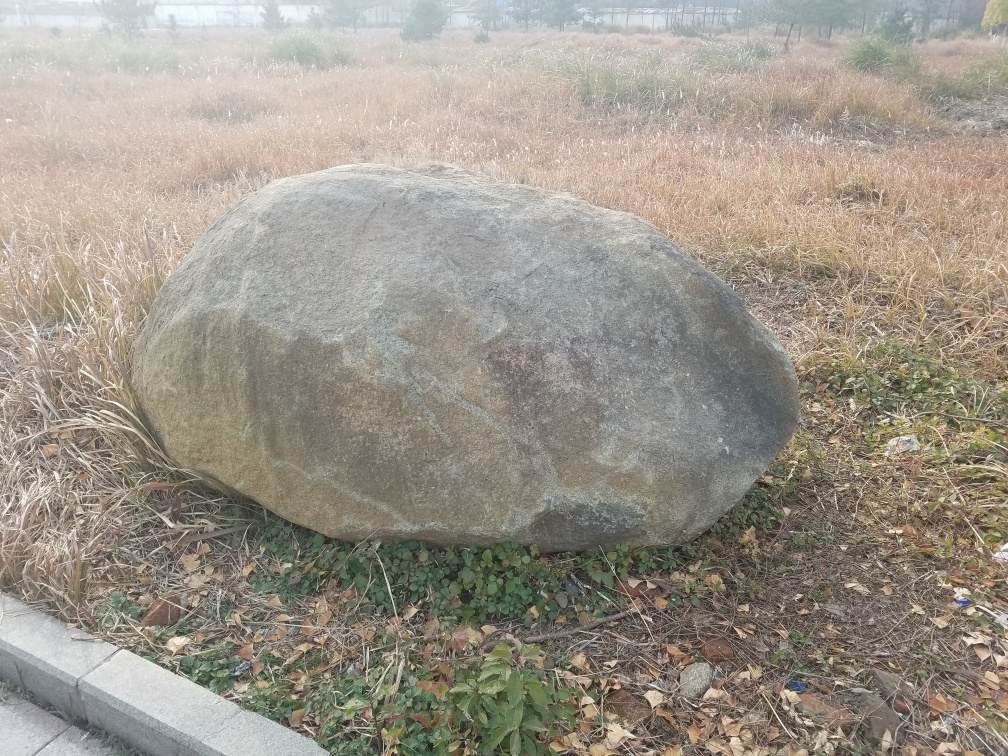What could be the geological significance of this boulder? Boulders like this one can be quite significant in geological terms. They are often transported by glacial ice or water flows from their original location, a process known as glacial erratic. Their composition, size, and location can give clues about past natural events, such as ice ages, floods, or the boulder's journey from its source. It would require an in-person examination or further context to provide more specific information about this boulder's geological history. 